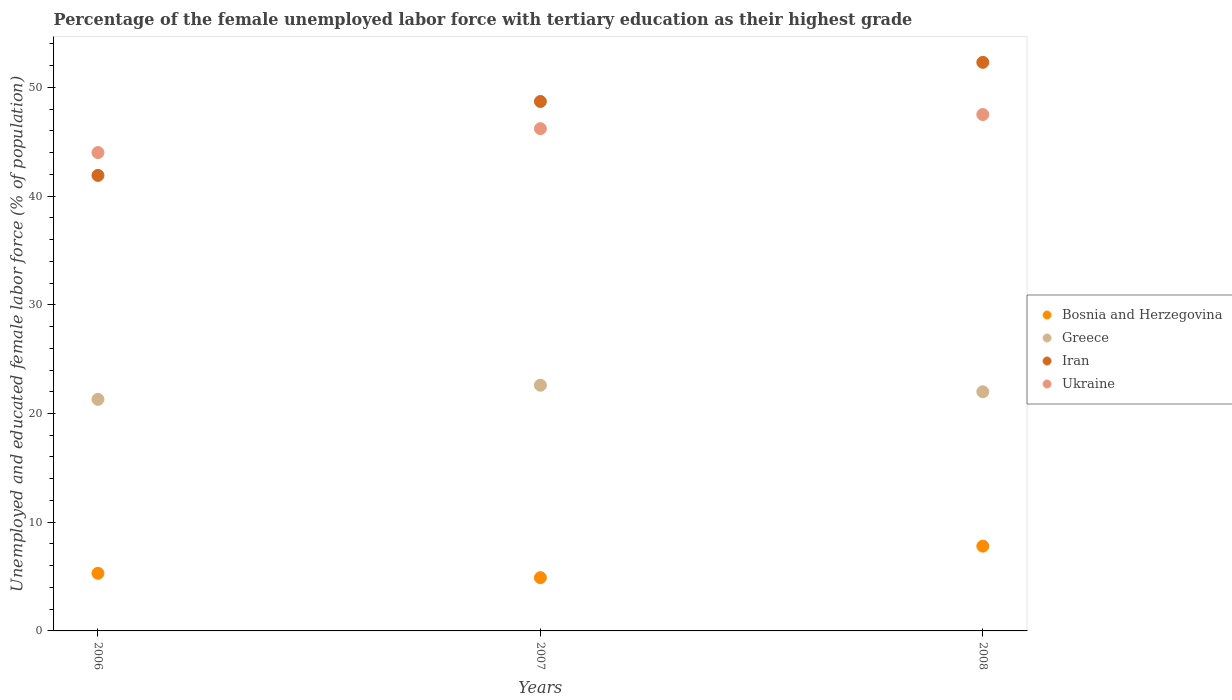What is the percentage of the unemployed female labor force with tertiary education in Ukraine in 2007?
Keep it short and to the point. 46.2. Across all years, what is the maximum percentage of the unemployed female labor force with tertiary education in Iran?
Offer a very short reply. 52.3. Across all years, what is the minimum percentage of the unemployed female labor force with tertiary education in Bosnia and Herzegovina?
Ensure brevity in your answer.  4.9. In which year was the percentage of the unemployed female labor force with tertiary education in Greece maximum?
Give a very brief answer. 2007. What is the total percentage of the unemployed female labor force with tertiary education in Greece in the graph?
Make the answer very short. 65.9. What is the difference between the percentage of the unemployed female labor force with tertiary education in Greece in 2006 and that in 2007?
Ensure brevity in your answer.  -1.3. What is the difference between the percentage of the unemployed female labor force with tertiary education in Ukraine in 2006 and the percentage of the unemployed female labor force with tertiary education in Bosnia and Herzegovina in 2007?
Provide a short and direct response. 39.1. What is the average percentage of the unemployed female labor force with tertiary education in Iran per year?
Provide a short and direct response. 47.63. In the year 2006, what is the difference between the percentage of the unemployed female labor force with tertiary education in Greece and percentage of the unemployed female labor force with tertiary education in Bosnia and Herzegovina?
Your answer should be very brief. 16. What is the ratio of the percentage of the unemployed female labor force with tertiary education in Greece in 2007 to that in 2008?
Offer a terse response. 1.03. What is the difference between the highest and the second highest percentage of the unemployed female labor force with tertiary education in Greece?
Provide a short and direct response. 0.6. In how many years, is the percentage of the unemployed female labor force with tertiary education in Ukraine greater than the average percentage of the unemployed female labor force with tertiary education in Ukraine taken over all years?
Offer a terse response. 2. Is the sum of the percentage of the unemployed female labor force with tertiary education in Greece in 2006 and 2008 greater than the maximum percentage of the unemployed female labor force with tertiary education in Iran across all years?
Your response must be concise. No. Is it the case that in every year, the sum of the percentage of the unemployed female labor force with tertiary education in Bosnia and Herzegovina and percentage of the unemployed female labor force with tertiary education in Ukraine  is greater than the sum of percentage of the unemployed female labor force with tertiary education in Iran and percentage of the unemployed female labor force with tertiary education in Greece?
Ensure brevity in your answer.  Yes. Is it the case that in every year, the sum of the percentage of the unemployed female labor force with tertiary education in Greece and percentage of the unemployed female labor force with tertiary education in Iran  is greater than the percentage of the unemployed female labor force with tertiary education in Bosnia and Herzegovina?
Provide a short and direct response. Yes. Is the percentage of the unemployed female labor force with tertiary education in Iran strictly less than the percentage of the unemployed female labor force with tertiary education in Greece over the years?
Your response must be concise. No. How many dotlines are there?
Your response must be concise. 4. What is the difference between two consecutive major ticks on the Y-axis?
Make the answer very short. 10. Are the values on the major ticks of Y-axis written in scientific E-notation?
Offer a terse response. No. How are the legend labels stacked?
Ensure brevity in your answer.  Vertical. What is the title of the graph?
Your answer should be very brief. Percentage of the female unemployed labor force with tertiary education as their highest grade. What is the label or title of the X-axis?
Offer a terse response. Years. What is the label or title of the Y-axis?
Make the answer very short. Unemployed and educated female labor force (% of population). What is the Unemployed and educated female labor force (% of population) of Bosnia and Herzegovina in 2006?
Offer a terse response. 5.3. What is the Unemployed and educated female labor force (% of population) of Greece in 2006?
Keep it short and to the point. 21.3. What is the Unemployed and educated female labor force (% of population) in Iran in 2006?
Provide a short and direct response. 41.9. What is the Unemployed and educated female labor force (% of population) of Bosnia and Herzegovina in 2007?
Ensure brevity in your answer.  4.9. What is the Unemployed and educated female labor force (% of population) of Greece in 2007?
Provide a short and direct response. 22.6. What is the Unemployed and educated female labor force (% of population) in Iran in 2007?
Make the answer very short. 48.7. What is the Unemployed and educated female labor force (% of population) in Ukraine in 2007?
Offer a terse response. 46.2. What is the Unemployed and educated female labor force (% of population) in Bosnia and Herzegovina in 2008?
Your response must be concise. 7.8. What is the Unemployed and educated female labor force (% of population) of Greece in 2008?
Provide a short and direct response. 22. What is the Unemployed and educated female labor force (% of population) in Iran in 2008?
Give a very brief answer. 52.3. What is the Unemployed and educated female labor force (% of population) of Ukraine in 2008?
Offer a terse response. 47.5. Across all years, what is the maximum Unemployed and educated female labor force (% of population) in Bosnia and Herzegovina?
Make the answer very short. 7.8. Across all years, what is the maximum Unemployed and educated female labor force (% of population) of Greece?
Your response must be concise. 22.6. Across all years, what is the maximum Unemployed and educated female labor force (% of population) in Iran?
Ensure brevity in your answer.  52.3. Across all years, what is the maximum Unemployed and educated female labor force (% of population) of Ukraine?
Provide a short and direct response. 47.5. Across all years, what is the minimum Unemployed and educated female labor force (% of population) of Bosnia and Herzegovina?
Your answer should be very brief. 4.9. Across all years, what is the minimum Unemployed and educated female labor force (% of population) in Greece?
Your answer should be compact. 21.3. Across all years, what is the minimum Unemployed and educated female labor force (% of population) in Iran?
Keep it short and to the point. 41.9. What is the total Unemployed and educated female labor force (% of population) in Bosnia and Herzegovina in the graph?
Keep it short and to the point. 18. What is the total Unemployed and educated female labor force (% of population) in Greece in the graph?
Provide a short and direct response. 65.9. What is the total Unemployed and educated female labor force (% of population) of Iran in the graph?
Offer a terse response. 142.9. What is the total Unemployed and educated female labor force (% of population) in Ukraine in the graph?
Make the answer very short. 137.7. What is the difference between the Unemployed and educated female labor force (% of population) in Bosnia and Herzegovina in 2006 and that in 2007?
Offer a very short reply. 0.4. What is the difference between the Unemployed and educated female labor force (% of population) of Greece in 2006 and that in 2007?
Offer a very short reply. -1.3. What is the difference between the Unemployed and educated female labor force (% of population) of Iran in 2006 and that in 2008?
Ensure brevity in your answer.  -10.4. What is the difference between the Unemployed and educated female labor force (% of population) in Ukraine in 2006 and that in 2008?
Provide a short and direct response. -3.5. What is the difference between the Unemployed and educated female labor force (% of population) of Iran in 2007 and that in 2008?
Give a very brief answer. -3.6. What is the difference between the Unemployed and educated female labor force (% of population) in Bosnia and Herzegovina in 2006 and the Unemployed and educated female labor force (% of population) in Greece in 2007?
Offer a terse response. -17.3. What is the difference between the Unemployed and educated female labor force (% of population) of Bosnia and Herzegovina in 2006 and the Unemployed and educated female labor force (% of population) of Iran in 2007?
Offer a terse response. -43.4. What is the difference between the Unemployed and educated female labor force (% of population) in Bosnia and Herzegovina in 2006 and the Unemployed and educated female labor force (% of population) in Ukraine in 2007?
Your answer should be very brief. -40.9. What is the difference between the Unemployed and educated female labor force (% of population) of Greece in 2006 and the Unemployed and educated female labor force (% of population) of Iran in 2007?
Your answer should be very brief. -27.4. What is the difference between the Unemployed and educated female labor force (% of population) of Greece in 2006 and the Unemployed and educated female labor force (% of population) of Ukraine in 2007?
Your response must be concise. -24.9. What is the difference between the Unemployed and educated female labor force (% of population) in Iran in 2006 and the Unemployed and educated female labor force (% of population) in Ukraine in 2007?
Provide a short and direct response. -4.3. What is the difference between the Unemployed and educated female labor force (% of population) in Bosnia and Herzegovina in 2006 and the Unemployed and educated female labor force (% of population) in Greece in 2008?
Offer a very short reply. -16.7. What is the difference between the Unemployed and educated female labor force (% of population) in Bosnia and Herzegovina in 2006 and the Unemployed and educated female labor force (% of population) in Iran in 2008?
Your response must be concise. -47. What is the difference between the Unemployed and educated female labor force (% of population) in Bosnia and Herzegovina in 2006 and the Unemployed and educated female labor force (% of population) in Ukraine in 2008?
Your answer should be compact. -42.2. What is the difference between the Unemployed and educated female labor force (% of population) of Greece in 2006 and the Unemployed and educated female labor force (% of population) of Iran in 2008?
Keep it short and to the point. -31. What is the difference between the Unemployed and educated female labor force (% of population) of Greece in 2006 and the Unemployed and educated female labor force (% of population) of Ukraine in 2008?
Keep it short and to the point. -26.2. What is the difference between the Unemployed and educated female labor force (% of population) of Bosnia and Herzegovina in 2007 and the Unemployed and educated female labor force (% of population) of Greece in 2008?
Your answer should be compact. -17.1. What is the difference between the Unemployed and educated female labor force (% of population) in Bosnia and Herzegovina in 2007 and the Unemployed and educated female labor force (% of population) in Iran in 2008?
Keep it short and to the point. -47.4. What is the difference between the Unemployed and educated female labor force (% of population) of Bosnia and Herzegovina in 2007 and the Unemployed and educated female labor force (% of population) of Ukraine in 2008?
Your response must be concise. -42.6. What is the difference between the Unemployed and educated female labor force (% of population) of Greece in 2007 and the Unemployed and educated female labor force (% of population) of Iran in 2008?
Keep it short and to the point. -29.7. What is the difference between the Unemployed and educated female labor force (% of population) of Greece in 2007 and the Unemployed and educated female labor force (% of population) of Ukraine in 2008?
Offer a very short reply. -24.9. What is the difference between the Unemployed and educated female labor force (% of population) of Iran in 2007 and the Unemployed and educated female labor force (% of population) of Ukraine in 2008?
Ensure brevity in your answer.  1.2. What is the average Unemployed and educated female labor force (% of population) of Bosnia and Herzegovina per year?
Offer a terse response. 6. What is the average Unemployed and educated female labor force (% of population) of Greece per year?
Offer a terse response. 21.97. What is the average Unemployed and educated female labor force (% of population) of Iran per year?
Your response must be concise. 47.63. What is the average Unemployed and educated female labor force (% of population) of Ukraine per year?
Keep it short and to the point. 45.9. In the year 2006, what is the difference between the Unemployed and educated female labor force (% of population) in Bosnia and Herzegovina and Unemployed and educated female labor force (% of population) in Greece?
Keep it short and to the point. -16. In the year 2006, what is the difference between the Unemployed and educated female labor force (% of population) in Bosnia and Herzegovina and Unemployed and educated female labor force (% of population) in Iran?
Ensure brevity in your answer.  -36.6. In the year 2006, what is the difference between the Unemployed and educated female labor force (% of population) in Bosnia and Herzegovina and Unemployed and educated female labor force (% of population) in Ukraine?
Provide a succinct answer. -38.7. In the year 2006, what is the difference between the Unemployed and educated female labor force (% of population) in Greece and Unemployed and educated female labor force (% of population) in Iran?
Offer a very short reply. -20.6. In the year 2006, what is the difference between the Unemployed and educated female labor force (% of population) in Greece and Unemployed and educated female labor force (% of population) in Ukraine?
Offer a very short reply. -22.7. In the year 2006, what is the difference between the Unemployed and educated female labor force (% of population) in Iran and Unemployed and educated female labor force (% of population) in Ukraine?
Your answer should be very brief. -2.1. In the year 2007, what is the difference between the Unemployed and educated female labor force (% of population) in Bosnia and Herzegovina and Unemployed and educated female labor force (% of population) in Greece?
Give a very brief answer. -17.7. In the year 2007, what is the difference between the Unemployed and educated female labor force (% of population) of Bosnia and Herzegovina and Unemployed and educated female labor force (% of population) of Iran?
Your answer should be very brief. -43.8. In the year 2007, what is the difference between the Unemployed and educated female labor force (% of population) of Bosnia and Herzegovina and Unemployed and educated female labor force (% of population) of Ukraine?
Offer a very short reply. -41.3. In the year 2007, what is the difference between the Unemployed and educated female labor force (% of population) of Greece and Unemployed and educated female labor force (% of population) of Iran?
Make the answer very short. -26.1. In the year 2007, what is the difference between the Unemployed and educated female labor force (% of population) of Greece and Unemployed and educated female labor force (% of population) of Ukraine?
Ensure brevity in your answer.  -23.6. In the year 2008, what is the difference between the Unemployed and educated female labor force (% of population) of Bosnia and Herzegovina and Unemployed and educated female labor force (% of population) of Greece?
Give a very brief answer. -14.2. In the year 2008, what is the difference between the Unemployed and educated female labor force (% of population) of Bosnia and Herzegovina and Unemployed and educated female labor force (% of population) of Iran?
Offer a very short reply. -44.5. In the year 2008, what is the difference between the Unemployed and educated female labor force (% of population) in Bosnia and Herzegovina and Unemployed and educated female labor force (% of population) in Ukraine?
Offer a very short reply. -39.7. In the year 2008, what is the difference between the Unemployed and educated female labor force (% of population) of Greece and Unemployed and educated female labor force (% of population) of Iran?
Provide a short and direct response. -30.3. In the year 2008, what is the difference between the Unemployed and educated female labor force (% of population) of Greece and Unemployed and educated female labor force (% of population) of Ukraine?
Give a very brief answer. -25.5. What is the ratio of the Unemployed and educated female labor force (% of population) of Bosnia and Herzegovina in 2006 to that in 2007?
Give a very brief answer. 1.08. What is the ratio of the Unemployed and educated female labor force (% of population) in Greece in 2006 to that in 2007?
Provide a short and direct response. 0.94. What is the ratio of the Unemployed and educated female labor force (% of population) in Iran in 2006 to that in 2007?
Provide a succinct answer. 0.86. What is the ratio of the Unemployed and educated female labor force (% of population) of Ukraine in 2006 to that in 2007?
Ensure brevity in your answer.  0.95. What is the ratio of the Unemployed and educated female labor force (% of population) in Bosnia and Herzegovina in 2006 to that in 2008?
Ensure brevity in your answer.  0.68. What is the ratio of the Unemployed and educated female labor force (% of population) in Greece in 2006 to that in 2008?
Your response must be concise. 0.97. What is the ratio of the Unemployed and educated female labor force (% of population) in Iran in 2006 to that in 2008?
Your response must be concise. 0.8. What is the ratio of the Unemployed and educated female labor force (% of population) of Ukraine in 2006 to that in 2008?
Provide a succinct answer. 0.93. What is the ratio of the Unemployed and educated female labor force (% of population) in Bosnia and Herzegovina in 2007 to that in 2008?
Give a very brief answer. 0.63. What is the ratio of the Unemployed and educated female labor force (% of population) of Greece in 2007 to that in 2008?
Your answer should be very brief. 1.03. What is the ratio of the Unemployed and educated female labor force (% of population) of Iran in 2007 to that in 2008?
Ensure brevity in your answer.  0.93. What is the ratio of the Unemployed and educated female labor force (% of population) in Ukraine in 2007 to that in 2008?
Provide a short and direct response. 0.97. What is the difference between the highest and the second highest Unemployed and educated female labor force (% of population) of Bosnia and Herzegovina?
Your answer should be compact. 2.5. What is the difference between the highest and the second highest Unemployed and educated female labor force (% of population) in Ukraine?
Your answer should be compact. 1.3. What is the difference between the highest and the lowest Unemployed and educated female labor force (% of population) in Bosnia and Herzegovina?
Your response must be concise. 2.9. 